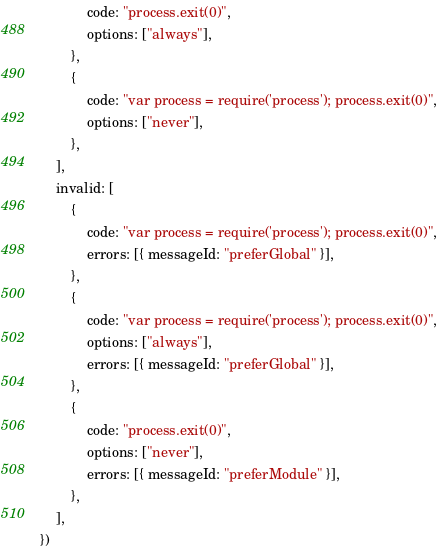Convert code to text. <code><loc_0><loc_0><loc_500><loc_500><_JavaScript_>            code: "process.exit(0)",
            options: ["always"],
        },
        {
            code: "var process = require('process'); process.exit(0)",
            options: ["never"],
        },
    ],
    invalid: [
        {
            code: "var process = require('process'); process.exit(0)",
            errors: [{ messageId: "preferGlobal" }],
        },
        {
            code: "var process = require('process'); process.exit(0)",
            options: ["always"],
            errors: [{ messageId: "preferGlobal" }],
        },
        {
            code: "process.exit(0)",
            options: ["never"],
            errors: [{ messageId: "preferModule" }],
        },
    ],
})
</code> 